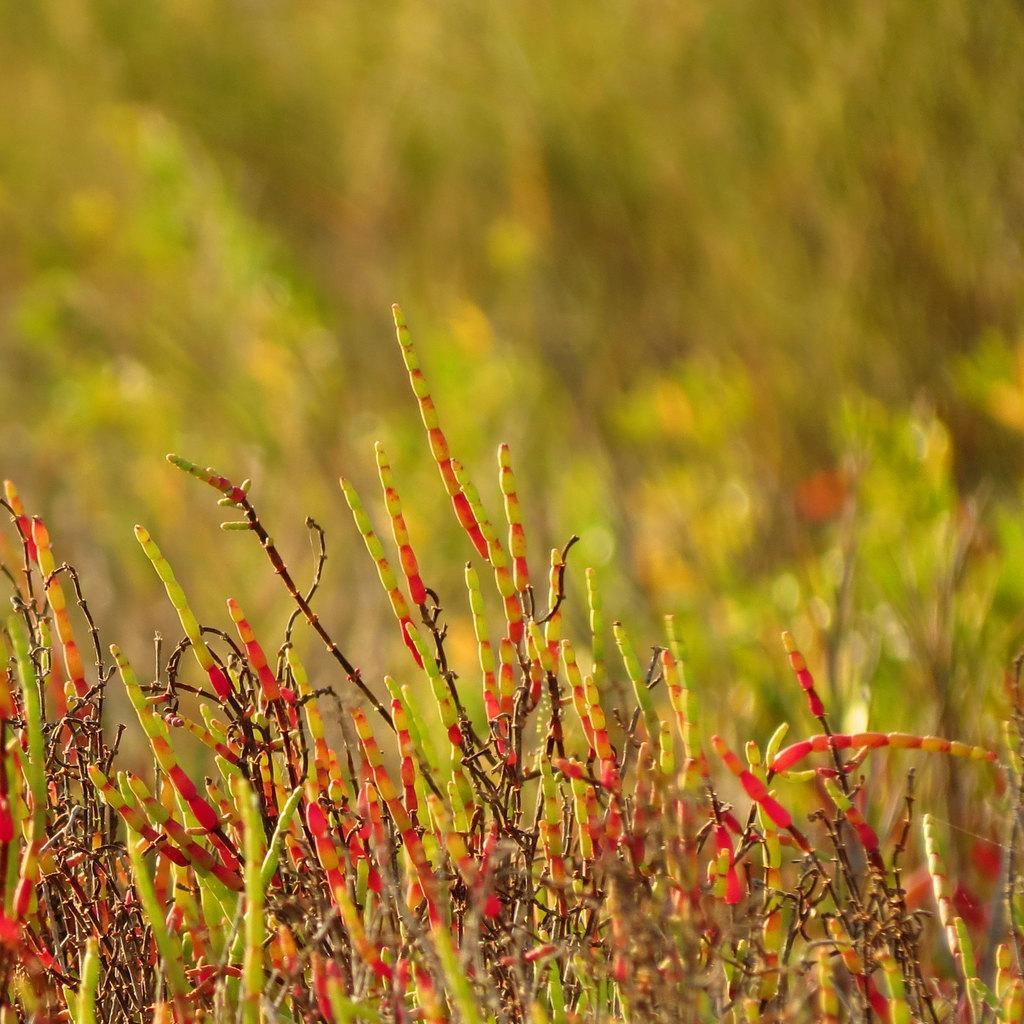Can you describe this image briefly? In this image, we can see planets and the background is blurry. 